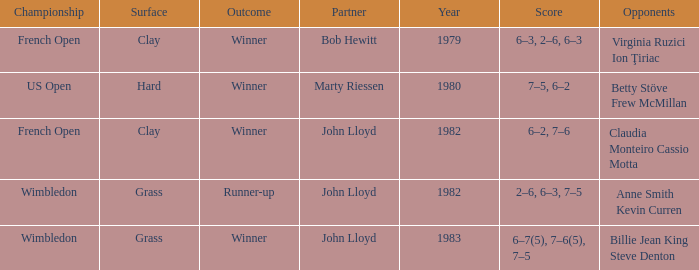What was the total number of matches that had an outcome of Winner, a partner of John Lloyd, and a clay surface? 1.0. 